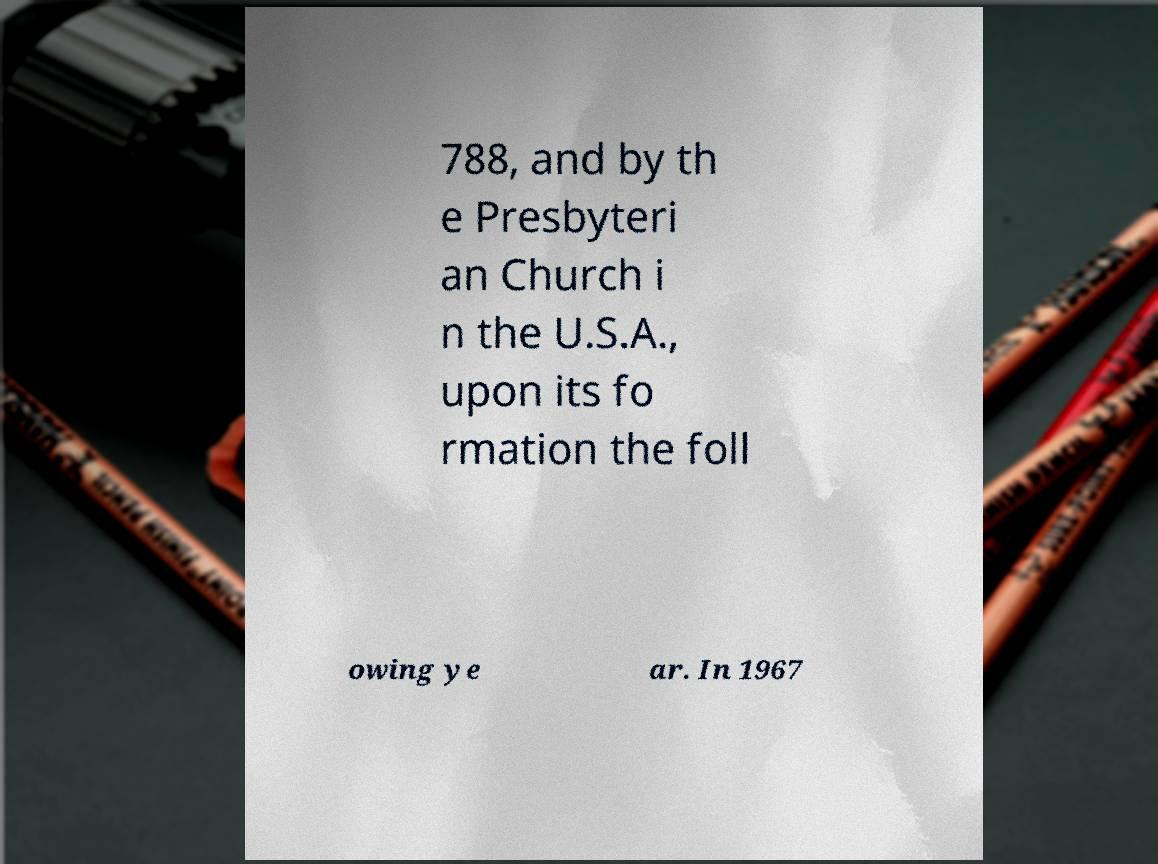Can you read and provide the text displayed in the image?This photo seems to have some interesting text. Can you extract and type it out for me? 788, and by th e Presbyteri an Church i n the U.S.A., upon its fo rmation the foll owing ye ar. In 1967 